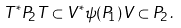Convert formula to latex. <formula><loc_0><loc_0><loc_500><loc_500>T ^ { * } P _ { 2 } T \subset V ^ { * } \psi ( P _ { 1 } ) V \subset P _ { 2 } \, .</formula> 